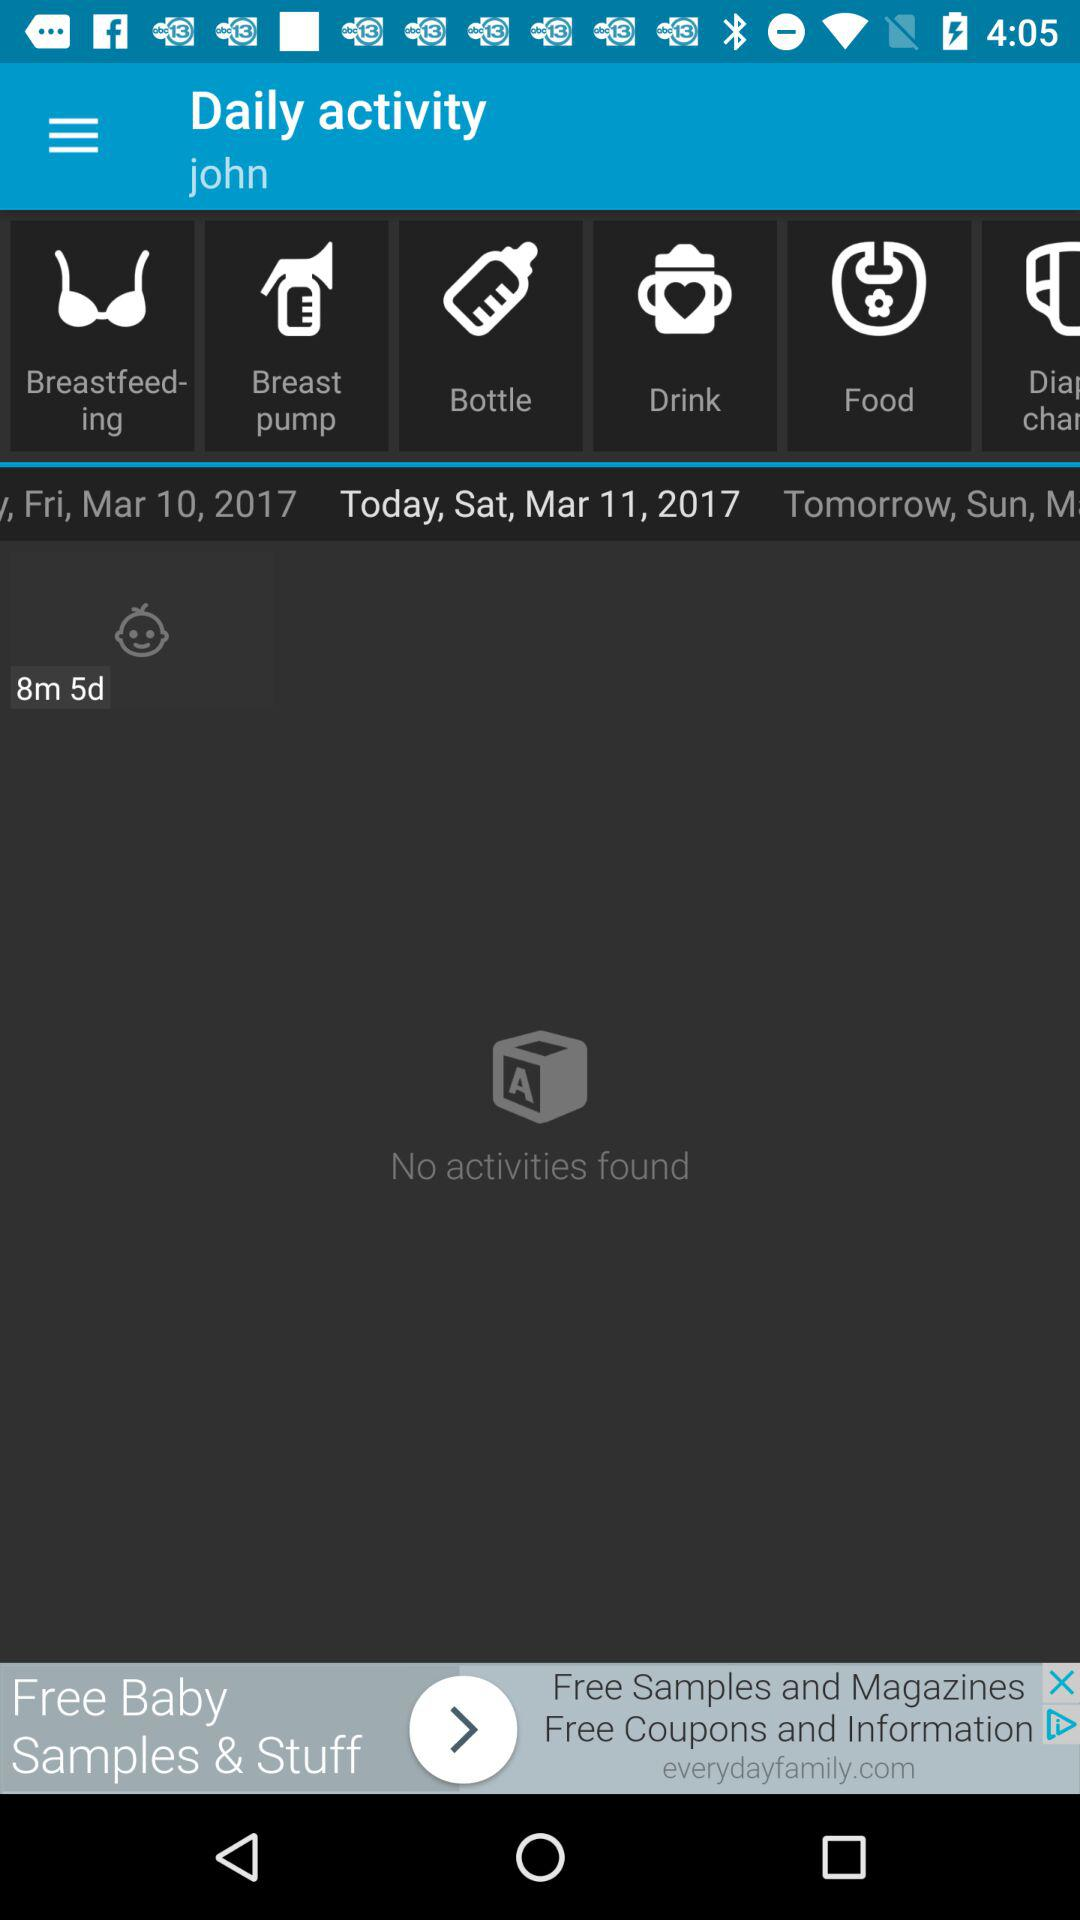What is the given profile name? The given profile name is John. 